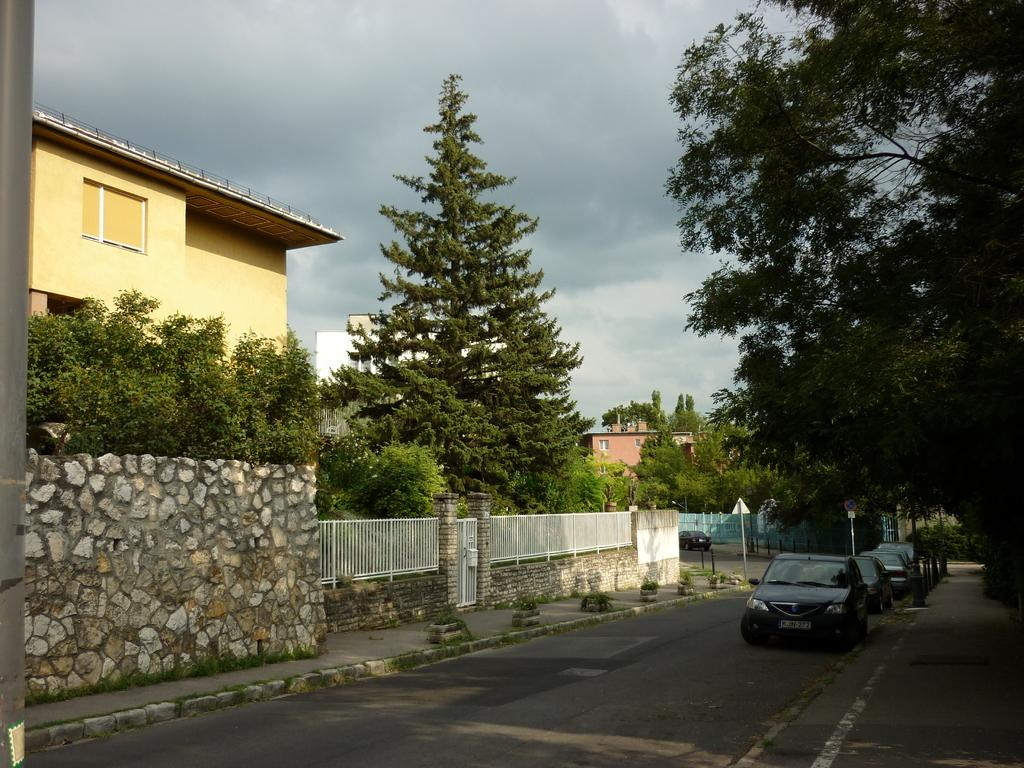What can be seen on the road in the image? There are vehicles on the road in the image. What is visible in the background of the image? The sky, clouds, trees, buildings, poles, and sign boards are visible in the background of the image. What hour is the clock tower displaying in the image? There is no clock tower present in the image, so it is not possible to determine the hour being displayed. 